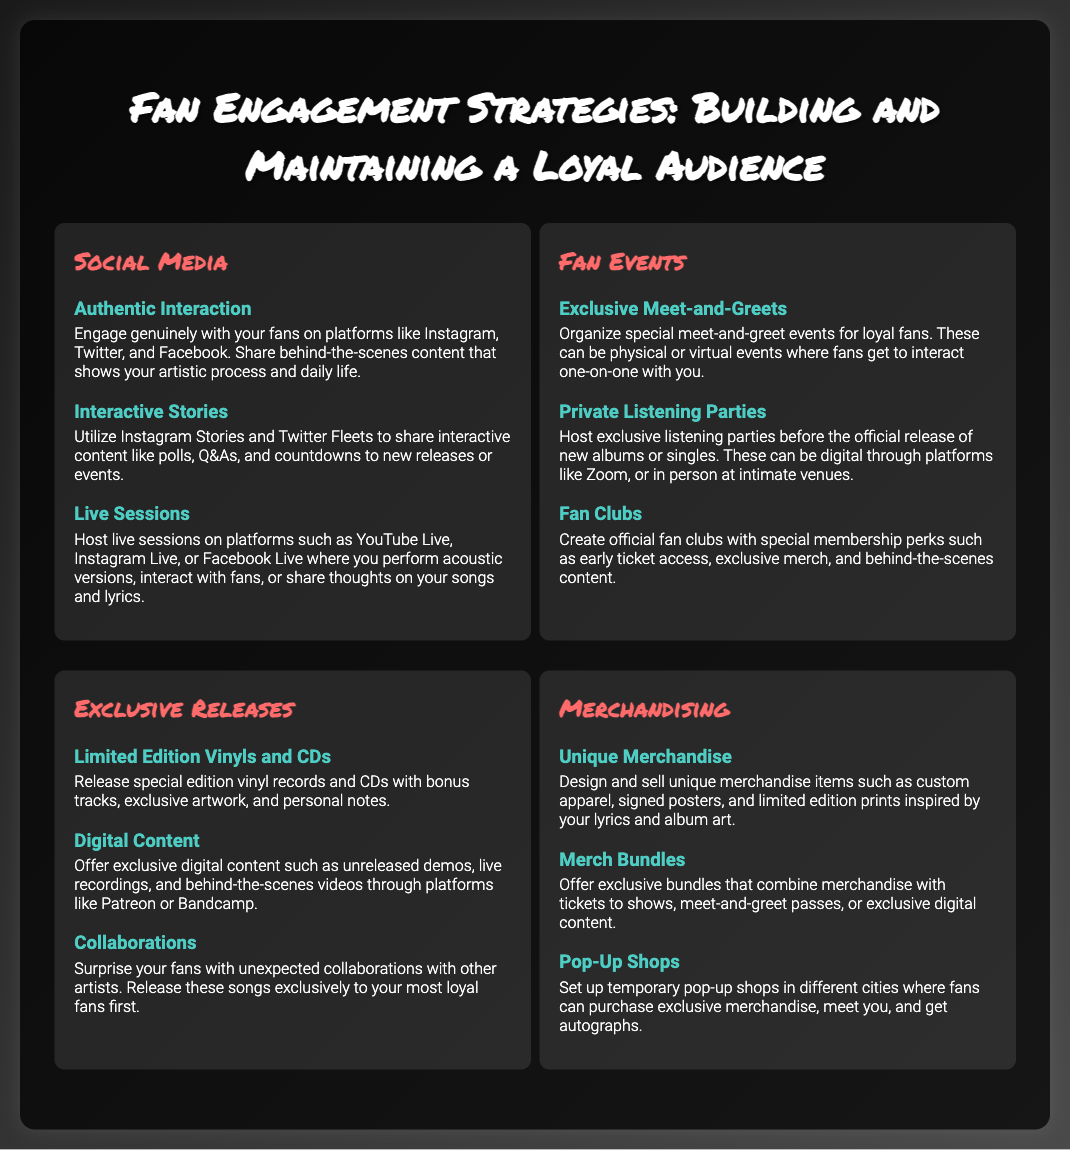What are the main strategies for fan engagement? The document outlines four main strategies: Social Media, Fan Events, Exclusive Releases, and Merchandising.
Answer: Social Media, Fan Events, Exclusive Releases, Merchandising What is a suggested event for loyal fans? The document mentions organizing special meet-and-greet events for loyal fans.
Answer: Meet-and-greets Which platform is recommended for live sessions? The document suggests hosting live sessions on platforms such as YouTube Live, Instagram Live, or Facebook Live.
Answer: YouTube Live, Instagram Live, Facebook Live What type of exclusive content can be released? The document specifies exclusive digital content like unreleased demos and live recordings through platforms like Patreon or Bandcamp.
Answer: Unreleased demos, live recordings What merchandise strategy involves combining items? The document discusses offering exclusive bundles that combine merchandise with tickets to shows.
Answer: Merch Bundles 